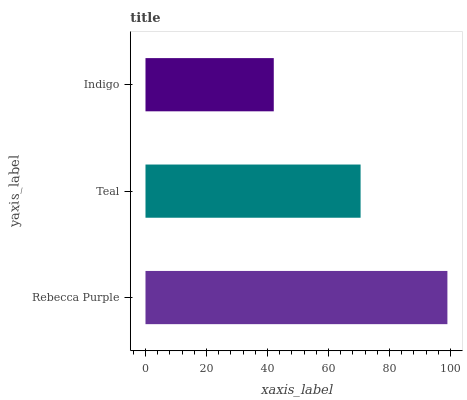Is Indigo the minimum?
Answer yes or no. Yes. Is Rebecca Purple the maximum?
Answer yes or no. Yes. Is Teal the minimum?
Answer yes or no. No. Is Teal the maximum?
Answer yes or no. No. Is Rebecca Purple greater than Teal?
Answer yes or no. Yes. Is Teal less than Rebecca Purple?
Answer yes or no. Yes. Is Teal greater than Rebecca Purple?
Answer yes or no. No. Is Rebecca Purple less than Teal?
Answer yes or no. No. Is Teal the high median?
Answer yes or no. Yes. Is Teal the low median?
Answer yes or no. Yes. Is Indigo the high median?
Answer yes or no. No. Is Rebecca Purple the low median?
Answer yes or no. No. 